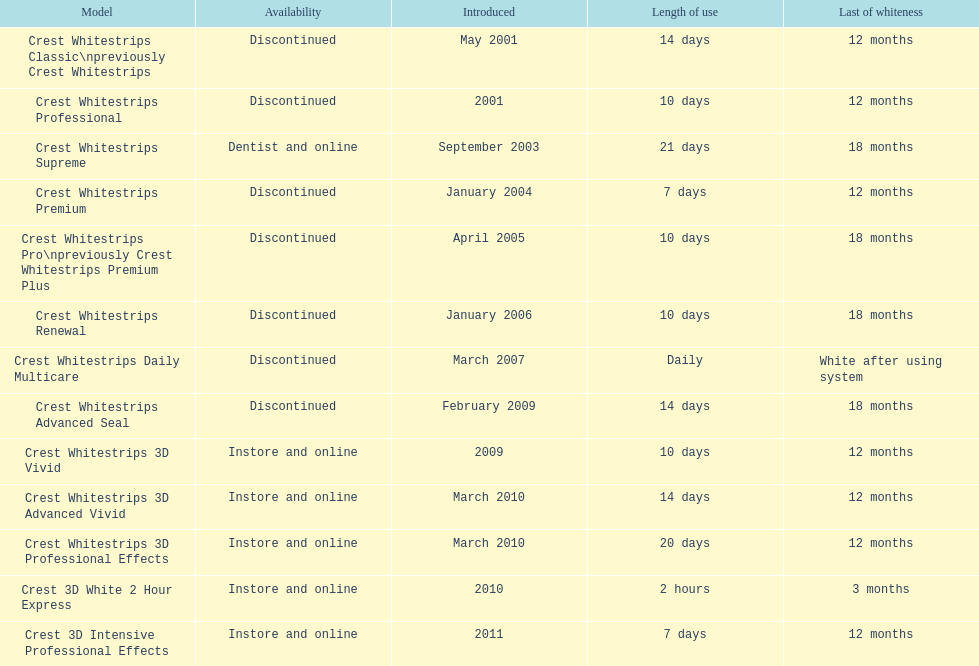How many models call for fewer than a week of operation? 2. 